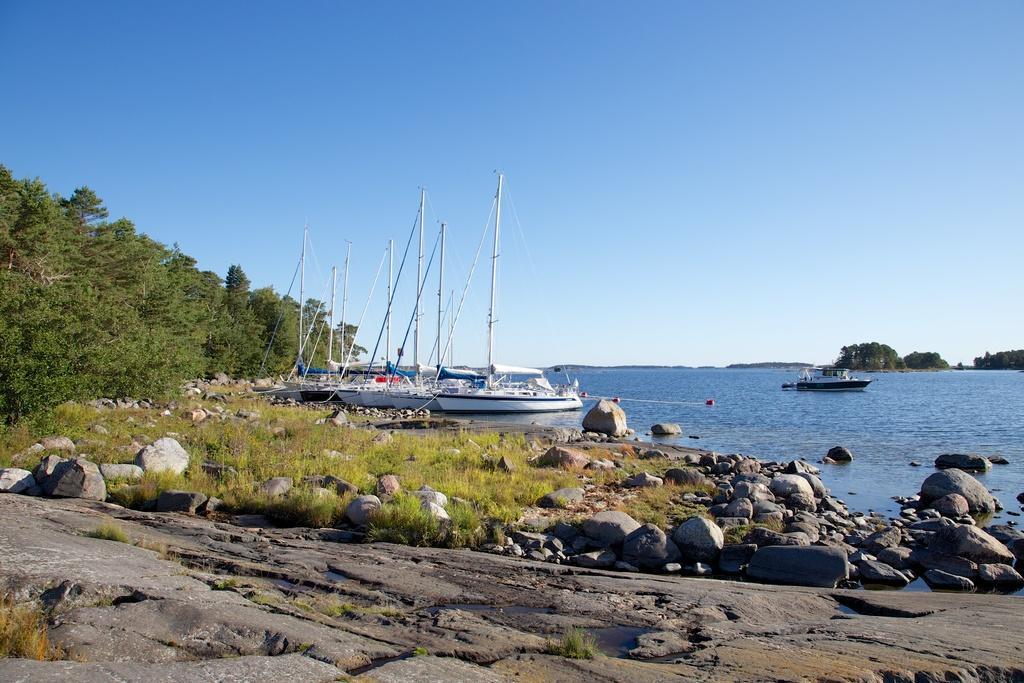How would you summarize this image in a sentence or two? In this image, we can see few boats are on the water. At the bottom, we can see stones, grass. Here there are so many trees. Background there is a clear sky. 